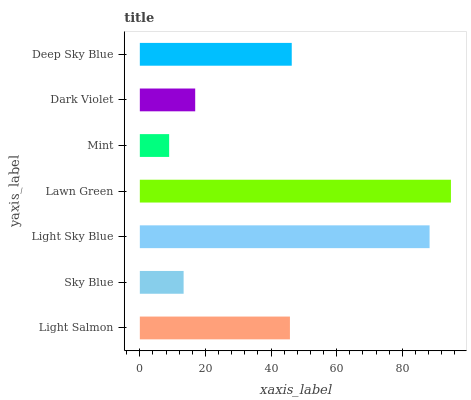Is Mint the minimum?
Answer yes or no. Yes. Is Lawn Green the maximum?
Answer yes or no. Yes. Is Sky Blue the minimum?
Answer yes or no. No. Is Sky Blue the maximum?
Answer yes or no. No. Is Light Salmon greater than Sky Blue?
Answer yes or no. Yes. Is Sky Blue less than Light Salmon?
Answer yes or no. Yes. Is Sky Blue greater than Light Salmon?
Answer yes or no. No. Is Light Salmon less than Sky Blue?
Answer yes or no. No. Is Light Salmon the high median?
Answer yes or no. Yes. Is Light Salmon the low median?
Answer yes or no. Yes. Is Sky Blue the high median?
Answer yes or no. No. Is Dark Violet the low median?
Answer yes or no. No. 